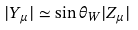<formula> <loc_0><loc_0><loc_500><loc_500>| Y _ { \mu } | \simeq \sin \theta _ { W } | Z _ { \mu } |</formula> 